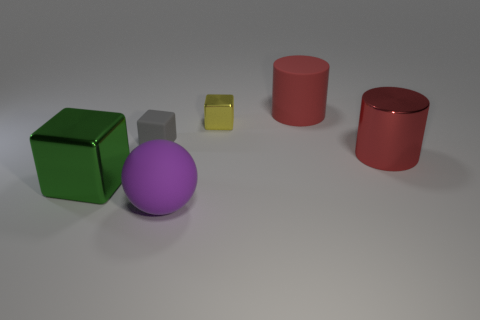There is a yellow object that is the same shape as the small gray thing; what is it made of?
Offer a very short reply. Metal. What number of spheres are either large red rubber things or red things?
Provide a short and direct response. 0. What number of blocks are the same material as the sphere?
Give a very brief answer. 1. Does the red cylinder in front of the small yellow metallic object have the same material as the big cube behind the purple rubber ball?
Your response must be concise. Yes. There is a big red cylinder that is behind the big metallic thing right of the large ball; how many big cylinders are on the left side of it?
Ensure brevity in your answer.  0. There is a big matte thing in front of the tiny rubber thing; is it the same color as the large metallic object on the left side of the big sphere?
Provide a succinct answer. No. Is there any other thing that has the same color as the big block?
Ensure brevity in your answer.  No. There is a large metallic object that is in front of the large metal thing right of the tiny matte cube; what is its color?
Provide a succinct answer. Green. Are there any big green things?
Keep it short and to the point. Yes. What color is the cube that is on the right side of the big green metal object and on the left side of the yellow block?
Keep it short and to the point. Gray. 